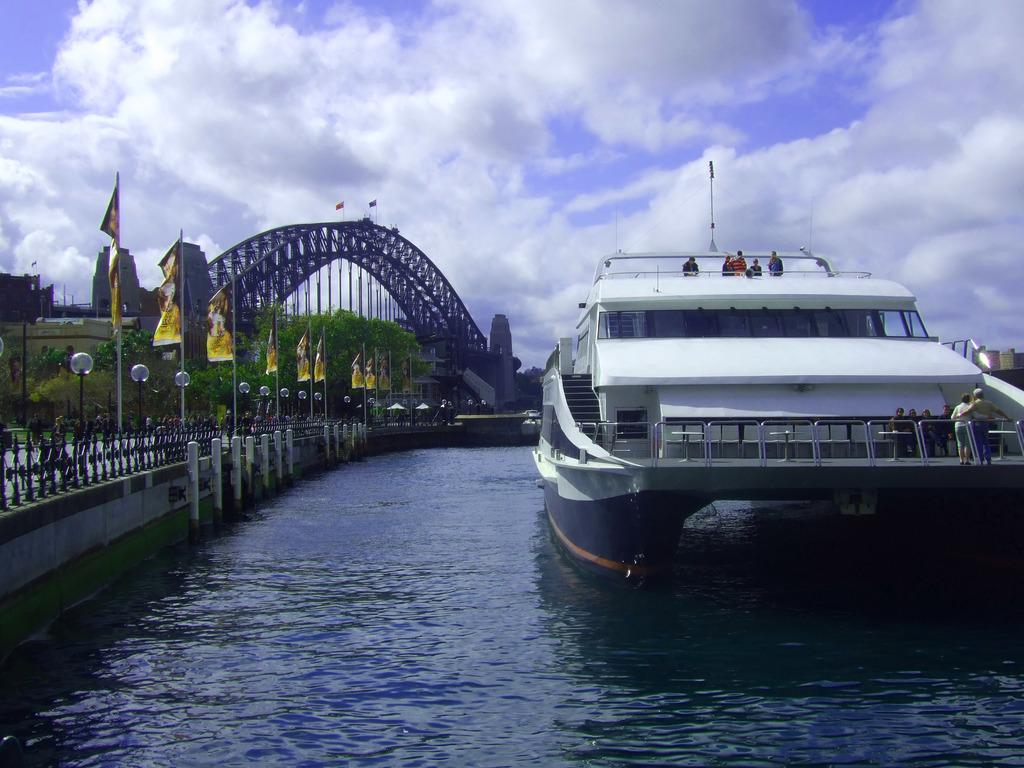Can you describe this image briefly? In this image I can see the ship on the water. To the left I can see the railing and flags. In the background I can see many trees, bridge, clouds and the sky. 